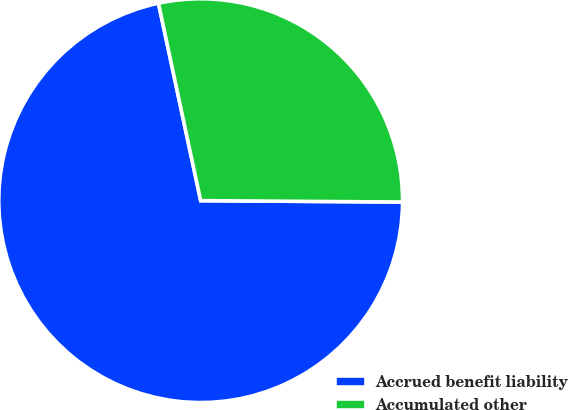Convert chart. <chart><loc_0><loc_0><loc_500><loc_500><pie_chart><fcel>Accrued benefit liability<fcel>Accumulated other<nl><fcel>71.54%<fcel>28.46%<nl></chart> 